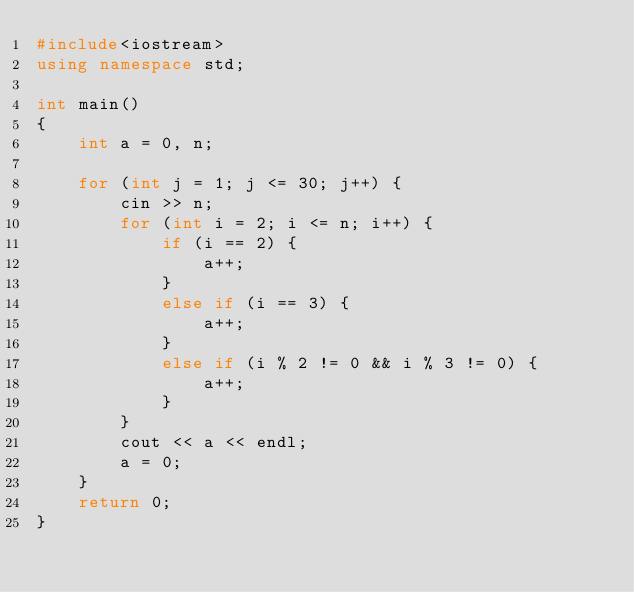Convert code to text. <code><loc_0><loc_0><loc_500><loc_500><_C++_>#include<iostream>
using namespace std;

int main()
{
	int a = 0, n;

	for (int j = 1; j <= 30; j++) {
		cin >> n;
		for (int i = 2; i <= n; i++) {
			if (i == 2) {
				a++;
			}
			else if (i == 3) {
				a++;
			}
			else if (i % 2 != 0 && i % 3 != 0) {
				a++;
			}
		}
		cout << a << endl;
		a = 0;
	}
	return 0;
}</code> 